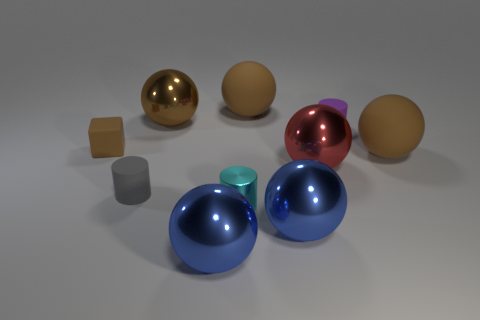Subtract all brown balls. How many were subtracted if there are1brown balls left? 2 Subtract all brown blocks. How many brown balls are left? 3 Subtract all blue spheres. How many spheres are left? 4 Subtract 3 balls. How many balls are left? 3 Subtract all brown shiny spheres. How many spheres are left? 5 Subtract all cyan balls. Subtract all red cylinders. How many balls are left? 6 Subtract all blocks. How many objects are left? 9 Add 4 small metal cylinders. How many small metal cylinders exist? 5 Subtract 0 purple spheres. How many objects are left? 10 Subtract all tiny things. Subtract all big blue rubber objects. How many objects are left? 6 